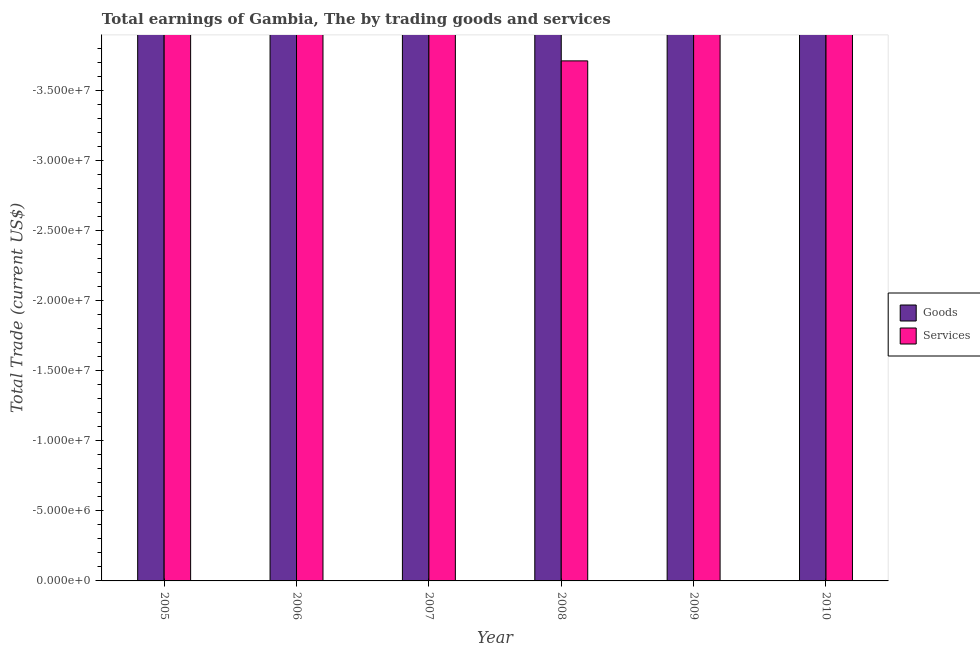In how many cases, is the number of bars for a given year not equal to the number of legend labels?
Your response must be concise. 6. What is the total amount earned by trading services in the graph?
Your answer should be very brief. 0. In how many years, is the amount earned by trading services greater than the average amount earned by trading services taken over all years?
Provide a succinct answer. 0. How many bars are there?
Provide a succinct answer. 0. Are all the bars in the graph horizontal?
Provide a succinct answer. No. How many years are there in the graph?
Provide a succinct answer. 6. What is the difference between two consecutive major ticks on the Y-axis?
Offer a terse response. 5.00e+06. Does the graph contain any zero values?
Keep it short and to the point. Yes. Does the graph contain grids?
Provide a succinct answer. No. How many legend labels are there?
Your answer should be very brief. 2. What is the title of the graph?
Your answer should be very brief. Total earnings of Gambia, The by trading goods and services. Does "Current education expenditure" appear as one of the legend labels in the graph?
Your response must be concise. No. What is the label or title of the Y-axis?
Your response must be concise. Total Trade (current US$). What is the Total Trade (current US$) of Goods in 2005?
Give a very brief answer. 0. What is the Total Trade (current US$) of Goods in 2006?
Give a very brief answer. 0. What is the Total Trade (current US$) in Goods in 2007?
Offer a terse response. 0. What is the Total Trade (current US$) of Services in 2009?
Your answer should be very brief. 0. What is the total Total Trade (current US$) of Goods in the graph?
Provide a short and direct response. 0. What is the total Total Trade (current US$) of Services in the graph?
Give a very brief answer. 0. 